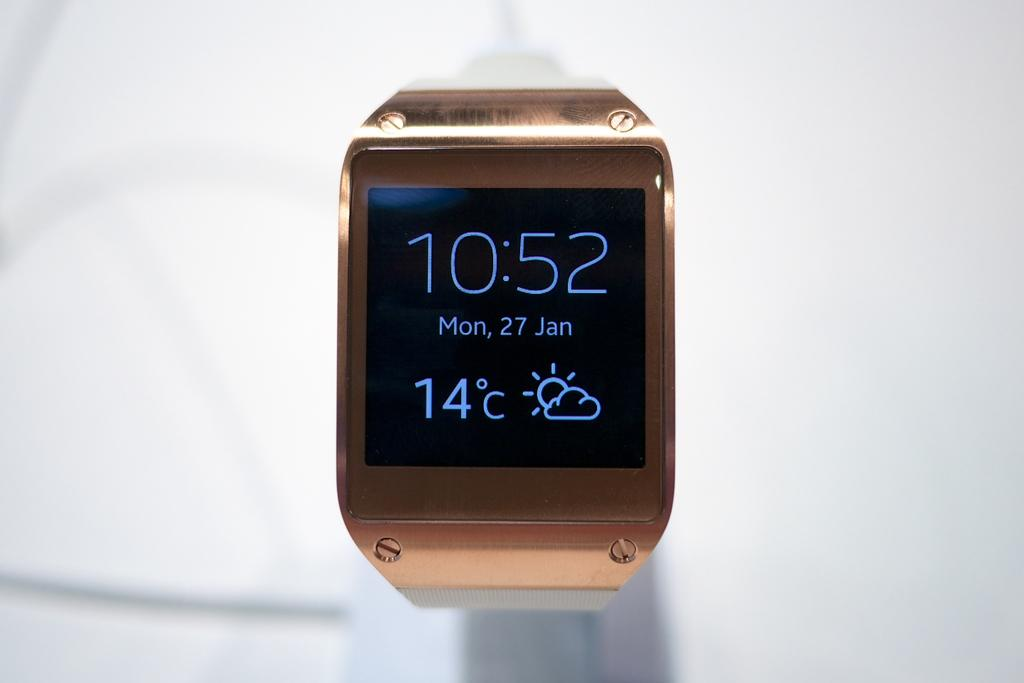<image>
Relay a brief, clear account of the picture shown. A smart watch shows the date is January 27th. 